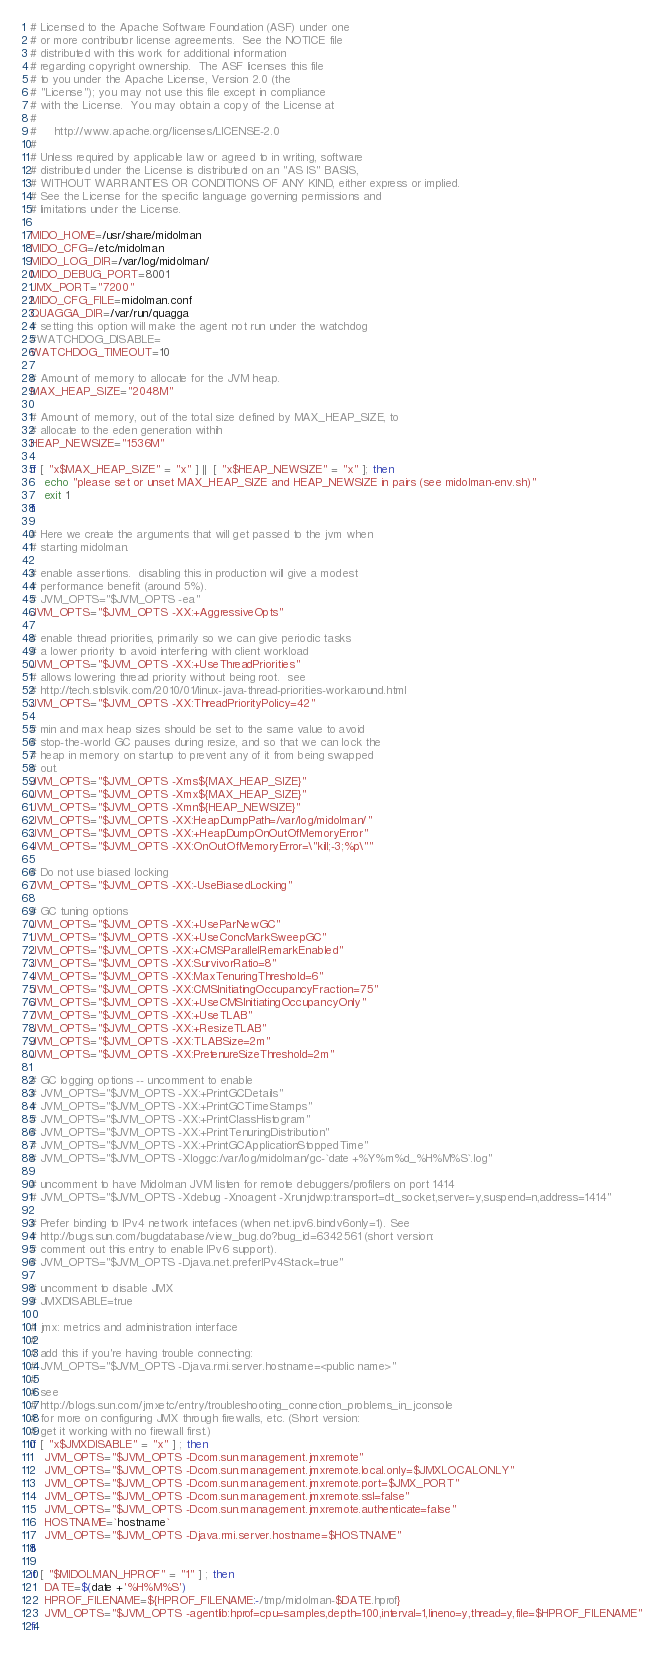Convert code to text. <code><loc_0><loc_0><loc_500><loc_500><_Bash_># Licensed to the Apache Software Foundation (ASF) under one
# or more contributor license agreements.  See the NOTICE file
# distributed with this work for additional information
# regarding copyright ownership.  The ASF licenses this file
# to you under the Apache License, Version 2.0 (the
# "License"); you may not use this file except in compliance
# with the License.  You may obtain a copy of the License at
#
#     http://www.apache.org/licenses/LICENSE-2.0
#
# Unless required by applicable law or agreed to in writing, software
# distributed under the License is distributed on an "AS IS" BASIS,
# WITHOUT WARRANTIES OR CONDITIONS OF ANY KIND, either express or implied.
# See the License for the specific language governing permissions and
# limitations under the License.

MIDO_HOME=/usr/share/midolman
MIDO_CFG=/etc/midolman
MIDO_LOG_DIR=/var/log/midolman/
MIDO_DEBUG_PORT=8001
JMX_PORT="7200"
MIDO_CFG_FILE=midolman.conf
QUAGGA_DIR=/var/run/quagga
# setting this option will make the agent not run under the watchdog
#WATCHDOG_DISABLE=
WATCHDOG_TIMEOUT=10

# Amount of memory to allocate for the JVM heap.
MAX_HEAP_SIZE="2048M"

# Amount of memory, out of the total size defined by MAX_HEAP_SIZE, to 
# allocate to the eden generation withih
HEAP_NEWSIZE="1536M"

if [ "x$MAX_HEAP_SIZE" = "x" ] ||  [ "x$HEAP_NEWSIZE" = "x" ]; then
    echo "please set or unset MAX_HEAP_SIZE and HEAP_NEWSIZE in pairs (see midolman-env.sh)"
    exit 1
fi

# Here we create the arguments that will get passed to the jvm when
# starting midolman.

# enable assertions.  disabling this in production will give a modest
# performance benefit (around 5%).
# JVM_OPTS="$JVM_OPTS -ea"
JVM_OPTS="$JVM_OPTS -XX:+AggressiveOpts"

# enable thread priorities, primarily so we can give periodic tasks
# a lower priority to avoid interfering with client workload
JVM_OPTS="$JVM_OPTS -XX:+UseThreadPriorities"
# allows lowering thread priority without being root.  see
# http://tech.stolsvik.com/2010/01/linux-java-thread-priorities-workaround.html
JVM_OPTS="$JVM_OPTS -XX:ThreadPriorityPolicy=42"

# min and max heap sizes should be set to the same value to avoid
# stop-the-world GC pauses during resize, and so that we can lock the
# heap in memory on startup to prevent any of it from being swapped
# out.
JVM_OPTS="$JVM_OPTS -Xms${MAX_HEAP_SIZE}"
JVM_OPTS="$JVM_OPTS -Xmx${MAX_HEAP_SIZE}"
JVM_OPTS="$JVM_OPTS -Xmn${HEAP_NEWSIZE}"
JVM_OPTS="$JVM_OPTS -XX:HeapDumpPath=/var/log/midolman/"
JVM_OPTS="$JVM_OPTS -XX:+HeapDumpOnOutOfMemoryError"
JVM_OPTS="$JVM_OPTS -XX:OnOutOfMemoryError=\"kill;-3;%p\""

# Do not use biased locking
JVM_OPTS="$JVM_OPTS -XX:-UseBiasedLocking"

# GC tuning options
JVM_OPTS="$JVM_OPTS -XX:+UseParNewGC"
JVM_OPTS="$JVM_OPTS -XX:+UseConcMarkSweepGC"
JVM_OPTS="$JVM_OPTS -XX:+CMSParallelRemarkEnabled"
JVM_OPTS="$JVM_OPTS -XX:SurvivorRatio=8"
JVM_OPTS="$JVM_OPTS -XX:MaxTenuringThreshold=6"
JVM_OPTS="$JVM_OPTS -XX:CMSInitiatingOccupancyFraction=75"
JVM_OPTS="$JVM_OPTS -XX:+UseCMSInitiatingOccupancyOnly"
JVM_OPTS="$JVM_OPTS -XX:+UseTLAB"
JVM_OPTS="$JVM_OPTS -XX:+ResizeTLAB"
JVM_OPTS="$JVM_OPTS -XX:TLABSize=2m"
JVM_OPTS="$JVM_OPTS -XX:PretenureSizeThreshold=2m"

# GC logging options -- uncomment to enable
# JVM_OPTS="$JVM_OPTS -XX:+PrintGCDetails"
# JVM_OPTS="$JVM_OPTS -XX:+PrintGCTimeStamps"
# JVM_OPTS="$JVM_OPTS -XX:+PrintClassHistogram"
# JVM_OPTS="$JVM_OPTS -XX:+PrintTenuringDistribution"
# JVM_OPTS="$JVM_OPTS -XX:+PrintGCApplicationStoppedTime"
# JVM_OPTS="$JVM_OPTS -Xloggc:/var/log/midolman/gc-`date +%Y%m%d_%H%M%S`.log"

# uncomment to have Midolman JVM listen for remote debuggers/profilers on port 1414
# JVM_OPTS="$JVM_OPTS -Xdebug -Xnoagent -Xrunjdwp:transport=dt_socket,server=y,suspend=n,address=1414"

# Prefer binding to IPv4 network intefaces (when net.ipv6.bindv6only=1). See
# http://bugs.sun.com/bugdatabase/view_bug.do?bug_id=6342561 (short version:
# comment out this entry to enable IPv6 support).
# JVM_OPTS="$JVM_OPTS -Djava.net.preferIPv4Stack=true"

# uncomment to disable JMX
# JMXDISABLE=true

# jmx: metrics and administration interface
#
# add this if you're having trouble connecting:
# JVM_OPTS="$JVM_OPTS -Djava.rmi.server.hostname=<public name>"
#
# see
# http://blogs.sun.com/jmxetc/entry/troubleshooting_connection_problems_in_jconsole
# for more on configuring JMX through firewalls, etc. (Short version:
# get it working with no firewall first.)
if [ "x$JMXDISABLE" = "x" ] ; then
    JVM_OPTS="$JVM_OPTS -Dcom.sun.management.jmxremote"
    JVM_OPTS="$JVM_OPTS -Dcom.sun.management.jmxremote.local.only=$JMXLOCALONLY"
    JVM_OPTS="$JVM_OPTS -Dcom.sun.management.jmxremote.port=$JMX_PORT"
    JVM_OPTS="$JVM_OPTS -Dcom.sun.management.jmxremote.ssl=false"
    JVM_OPTS="$JVM_OPTS -Dcom.sun.management.jmxremote.authenticate=false"
    HOSTNAME=`hostname`
    JVM_OPTS="$JVM_OPTS -Djava.rmi.server.hostname=$HOSTNAME"
fi

if [ "$MIDOLMAN_HPROF" = "1" ] ; then
    DATE=$(date +'%H%M%S')
    HPROF_FILENAME=${HPROF_FILENAME:-/tmp/midolman-$DATE.hprof}
    JVM_OPTS="$JVM_OPTS -agentlib:hprof=cpu=samples,depth=100,interval=1,lineno=y,thread=y,file=$HPROF_FILENAME"
fi
</code> 